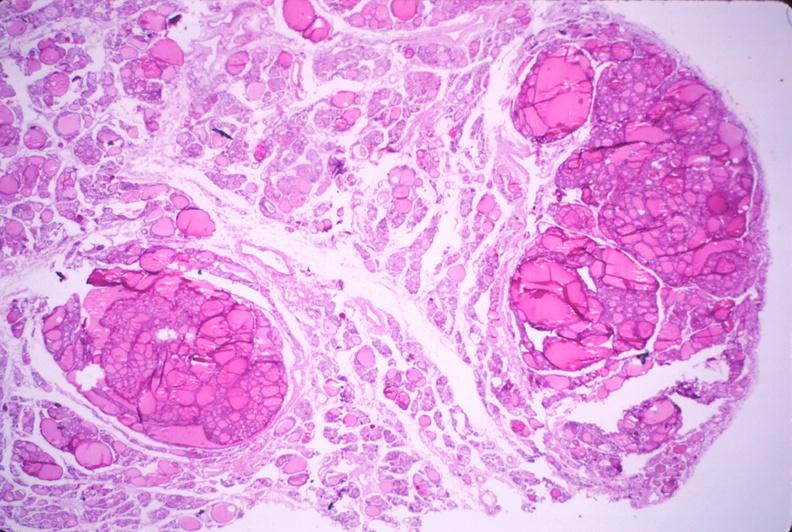s intraductal papillomatosis with apocrine metaplasia present?
Answer the question using a single word or phrase. No 